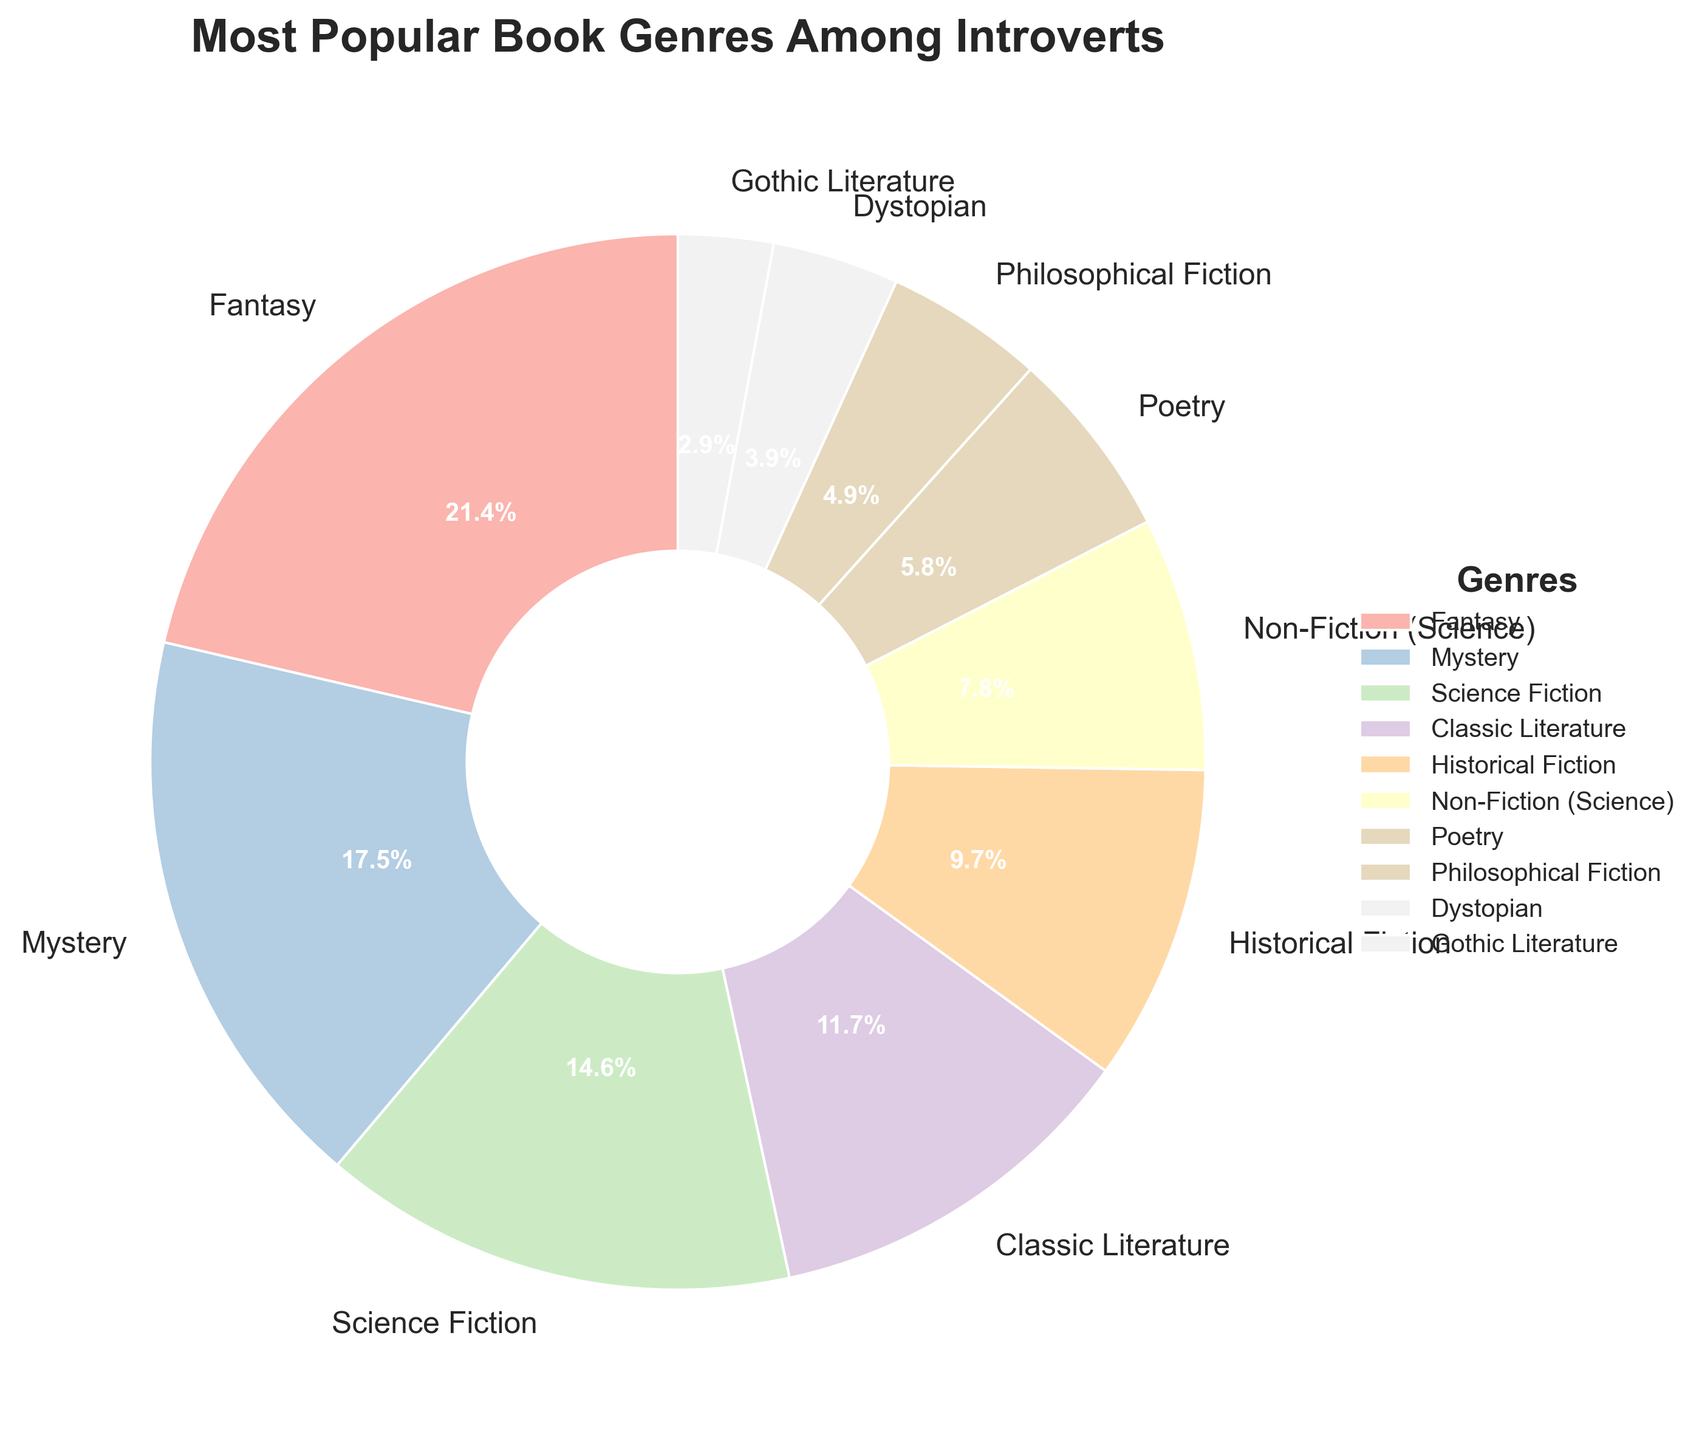What genre has the highest percentage among introverts? The figure shows each genre's percentage. Fantasy has the highest percentage at 22%.
Answer: Fantasy Which genres have a percentage less than 10%? To determine this, look at the segments with percentages under 10%. They are Historical Fiction (10%), Non-Fiction (Science) (8%), Poetry (6%), Philosophical Fiction (5%), Dystopian (4%), and Gothic Literature (3%).
Answer: Historical Fiction, Non-Fiction (Science), Poetry, Philosophical Fiction, Dystopian, Gothic Literature How much more popular is Fantasy compared to Dystopian? Fantasy is 22%, and Dystopian is 4%. Subtract Dystopian from Fantasy: 22% - 4% = 18%.
Answer: 18% Which genre is more popular, Mystery or Science Fiction? Compare the percentages of each genre. Mystery is 18%, and Science Fiction is 15%. Mystery is more popular.
Answer: Mystery What is the combined percentage of Fantasy and Science Fiction? Add the percentages of Fantasy (22%) and Science Fiction (15%): 22% + 15% = 37%.
Answer: 37% Which genre has the smallest percentage, and what is it? Find the smallest segment in the figure. Gothic Literature has the smallest percentage at 3%.
Answer: Gothic Literature, 3% Is Non-Fiction (Science) more popular than Poetry, and by how much? Compare their percentages: Non-Fiction (Science) is 8%, and Poetry is 6%. Subtract their percentages: 8% - 6% = 2%.
Answer: Yes, by 2% How do the percentages of Classic Literature and Historical Fiction compare? Classic Literature is 12%, and Historical Fiction is 10%. Classic Literature is 2% more.
Answer: Classic Literature is 2% more What is the average percentage of the genres that constitute less than 10%? Sum the percentages of these genres: 10% (Historical Fiction) + 8% (Non-Fiction) + 6% (Poetry) + 5% (Philosophical Fiction) + 4% (Dystopian) + 3% (Gothic Literature) = 36%. Divide by the number of genres (6): 36% / 6 = 6%.
Answer: 6% Which genre has a percentage closest to 10%? Among the provided percentages, Historical Fiction has exactly 10%.
Answer: Historical Fiction 